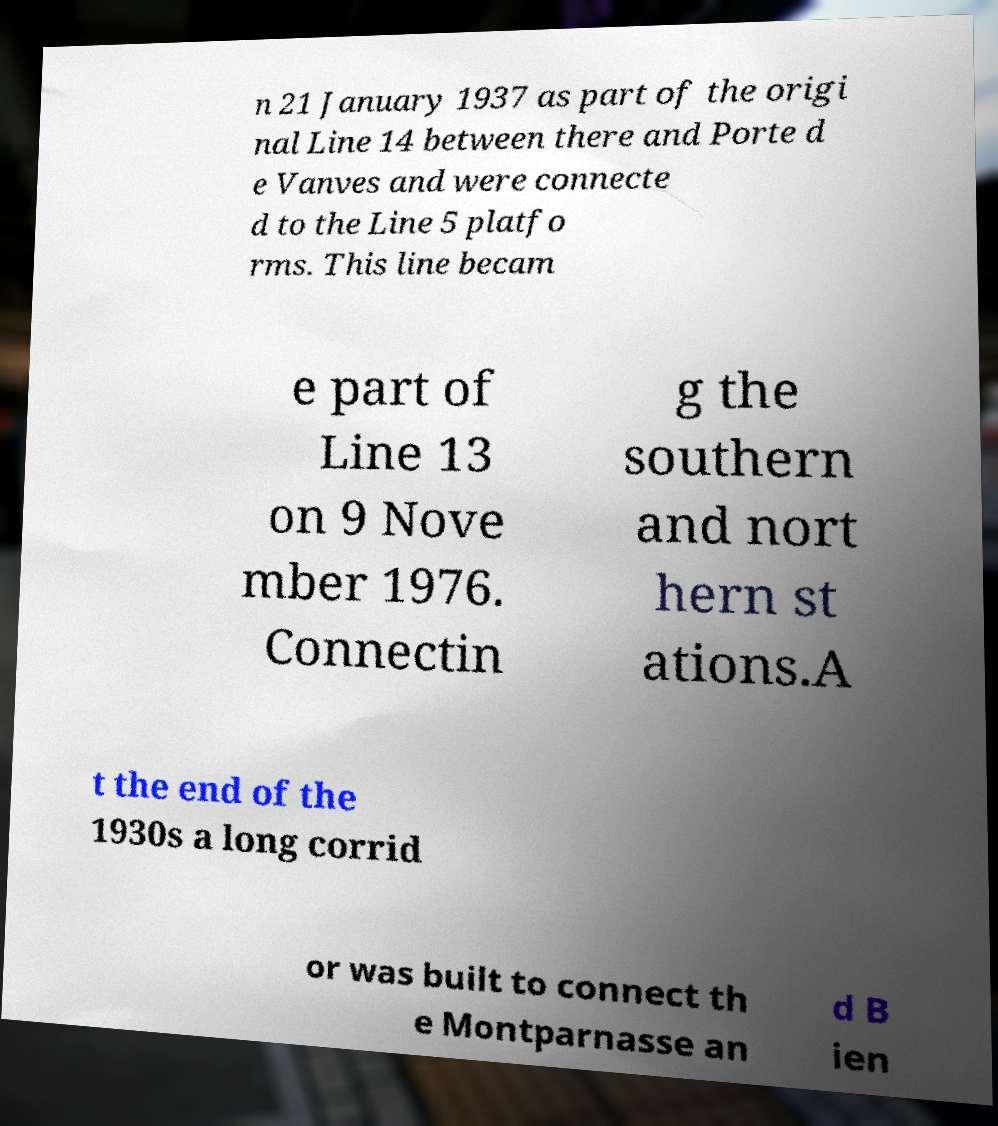Could you extract and type out the text from this image? n 21 January 1937 as part of the origi nal Line 14 between there and Porte d e Vanves and were connecte d to the Line 5 platfo rms. This line becam e part of Line 13 on 9 Nove mber 1976. Connectin g the southern and nort hern st ations.A t the end of the 1930s a long corrid or was built to connect th e Montparnasse an d B ien 